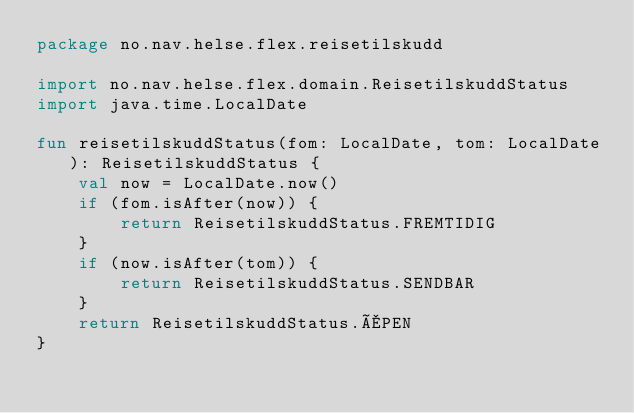<code> <loc_0><loc_0><loc_500><loc_500><_Kotlin_>package no.nav.helse.flex.reisetilskudd

import no.nav.helse.flex.domain.ReisetilskuddStatus
import java.time.LocalDate

fun reisetilskuddStatus(fom: LocalDate, tom: LocalDate): ReisetilskuddStatus {
    val now = LocalDate.now()
    if (fom.isAfter(now)) {
        return ReisetilskuddStatus.FREMTIDIG
    }
    if (now.isAfter(tom)) {
        return ReisetilskuddStatus.SENDBAR
    }
    return ReisetilskuddStatus.ÅPEN
}
</code> 